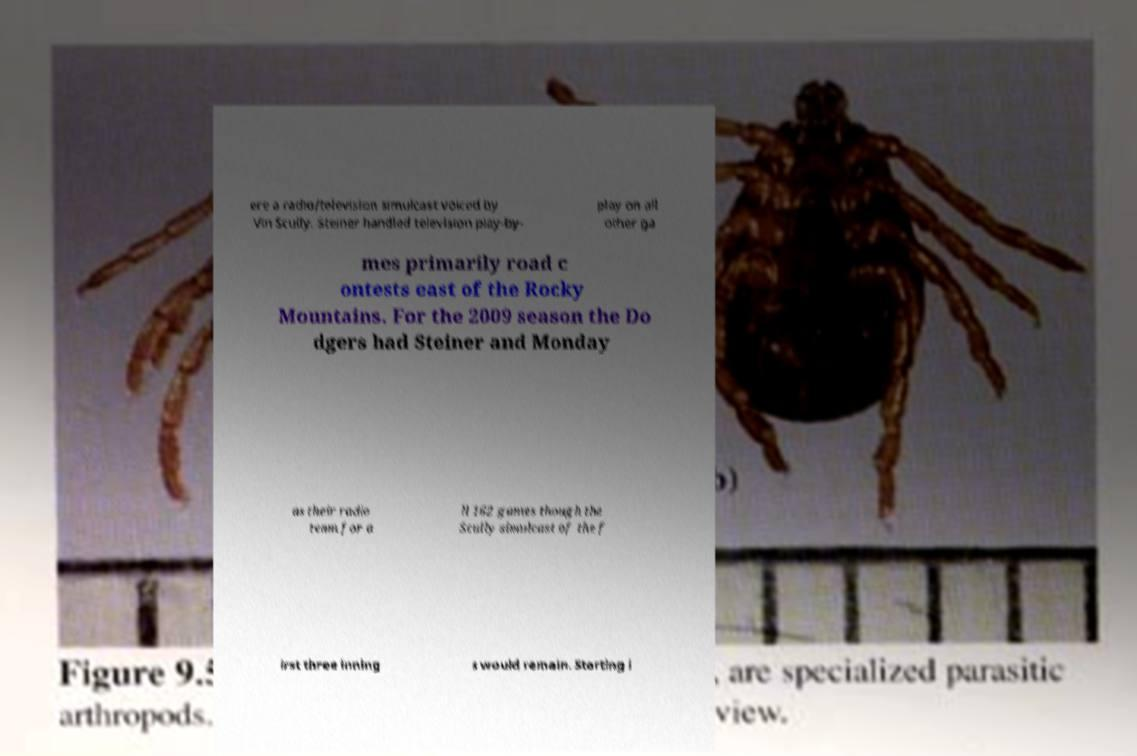Could you extract and type out the text from this image? ere a radio/television simulcast voiced by Vin Scully. Steiner handled television play-by- play on all other ga mes primarily road c ontests east of the Rocky Mountains. For the 2009 season the Do dgers had Steiner and Monday as their radio team for a ll 162 games though the Scully simulcast of the f irst three inning s would remain. Starting i 